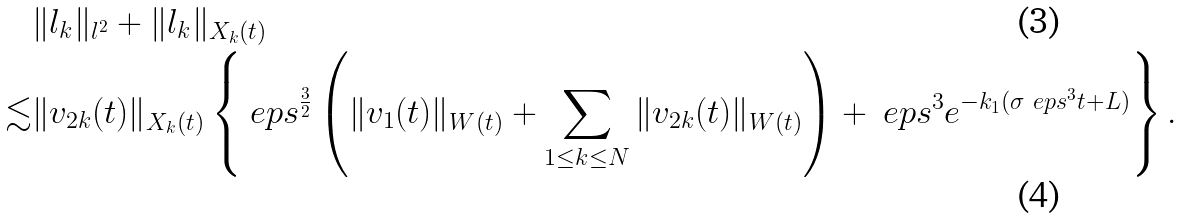Convert formula to latex. <formula><loc_0><loc_0><loc_500><loc_500>& \| l _ { k } \| _ { l ^ { 2 } } + \| l _ { k } \| _ { X _ { k } ( t ) } \\ \lesssim & \| v _ { 2 k } ( t ) \| _ { X _ { k } ( t ) } \left \{ \ e p s ^ { \frac { 3 } { 2 } } \left ( \| v _ { 1 } ( t ) \| _ { W ( t ) } + \sum _ { 1 \leq k \leq N } \| v _ { 2 k } ( t ) \| _ { W ( t ) } \right ) + \ e p s ^ { 3 } e ^ { - k _ { 1 } ( \sigma \ e p s ^ { 3 } t + L ) } \right \} .</formula> 